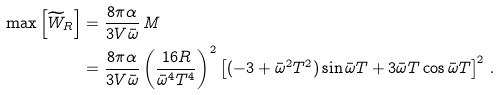<formula> <loc_0><loc_0><loc_500><loc_500>\max \left [ \widetilde { W } _ { R } \right ] & = \frac { 8 \pi \alpha } { 3 V \bar { \omega } } \, M \\ & = \frac { 8 \pi \alpha } { 3 V \bar { \omega } } \left ( \frac { 1 6 R } { \bar { \omega } ^ { 4 } T ^ { 4 } } \right ) ^ { 2 } \left [ ( - 3 + \bar { \omega } ^ { 2 } T ^ { 2 } ) \sin \bar { \omega } T + 3 \bar { \omega } T \cos \bar { \omega } T \right ] ^ { 2 } \, .</formula> 